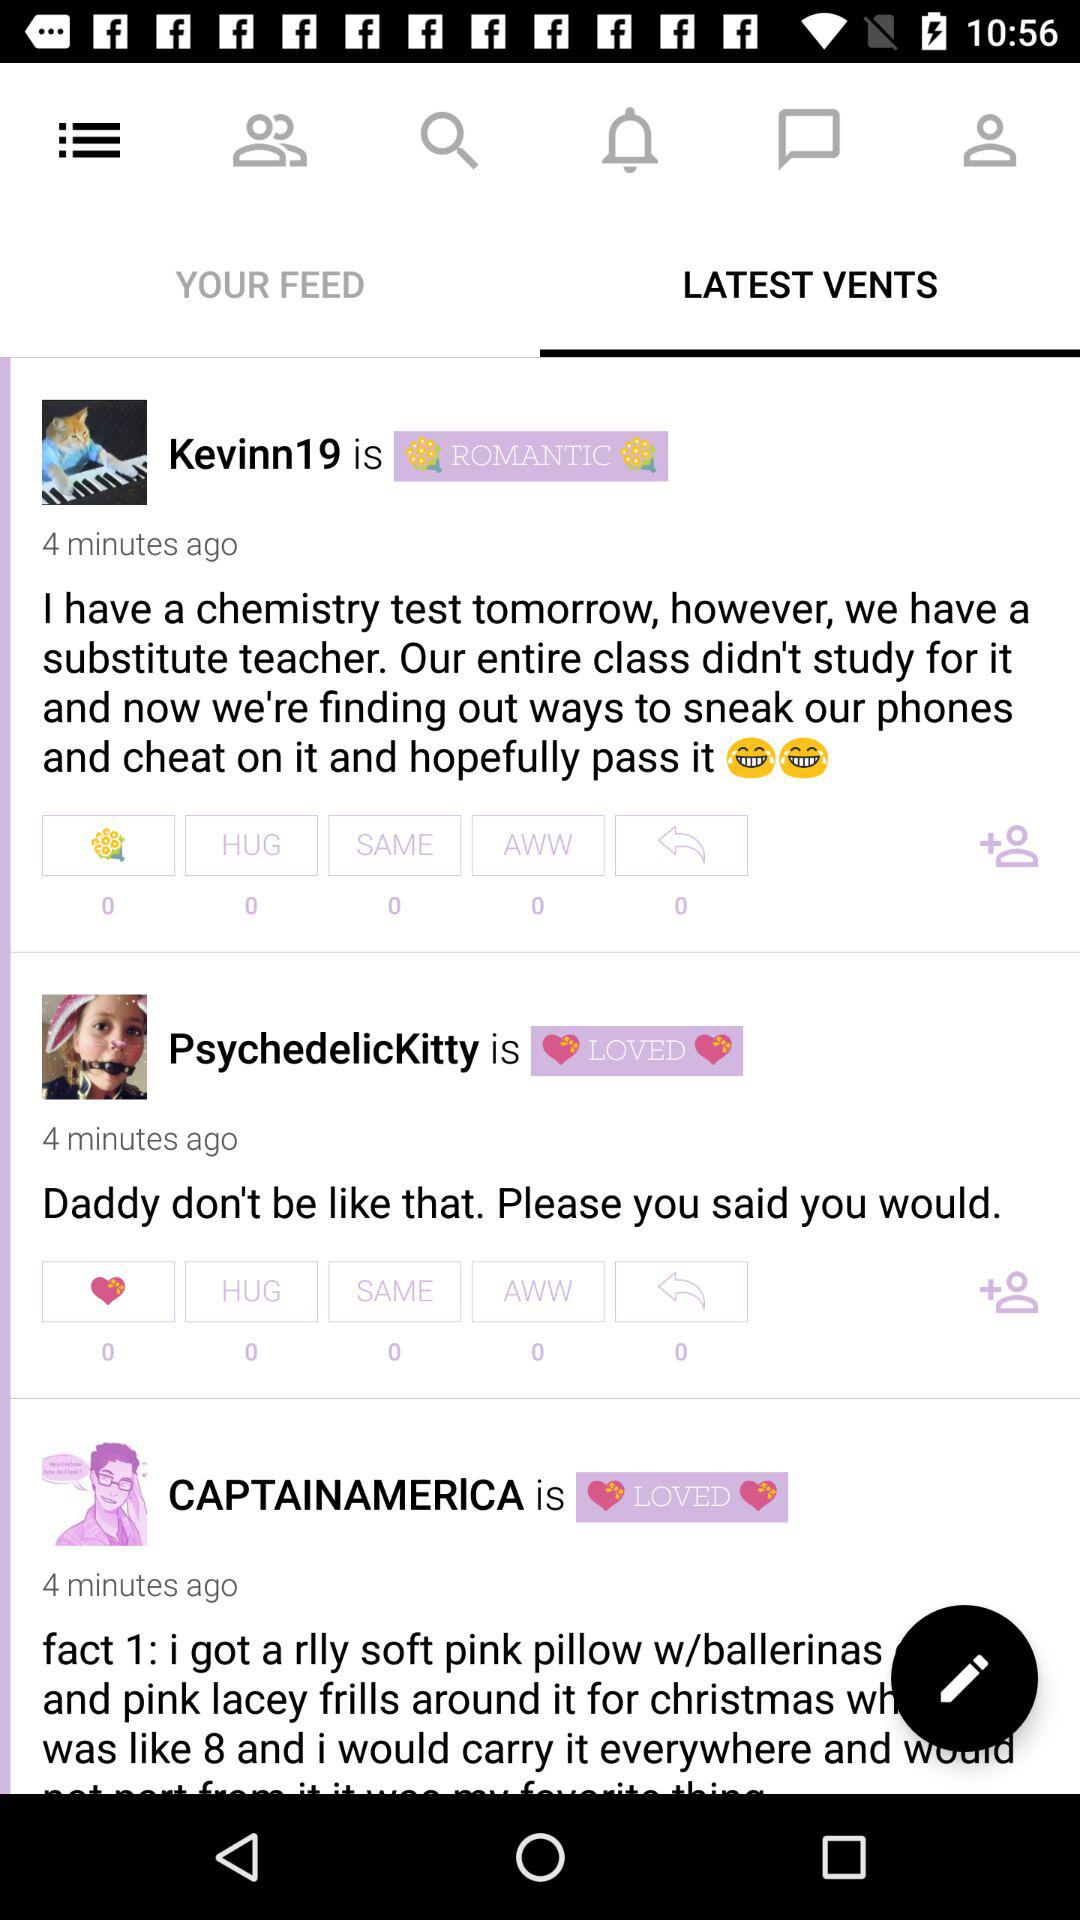How many of the vent items have a heart emoji?
Answer the question using a single word or phrase. 2 